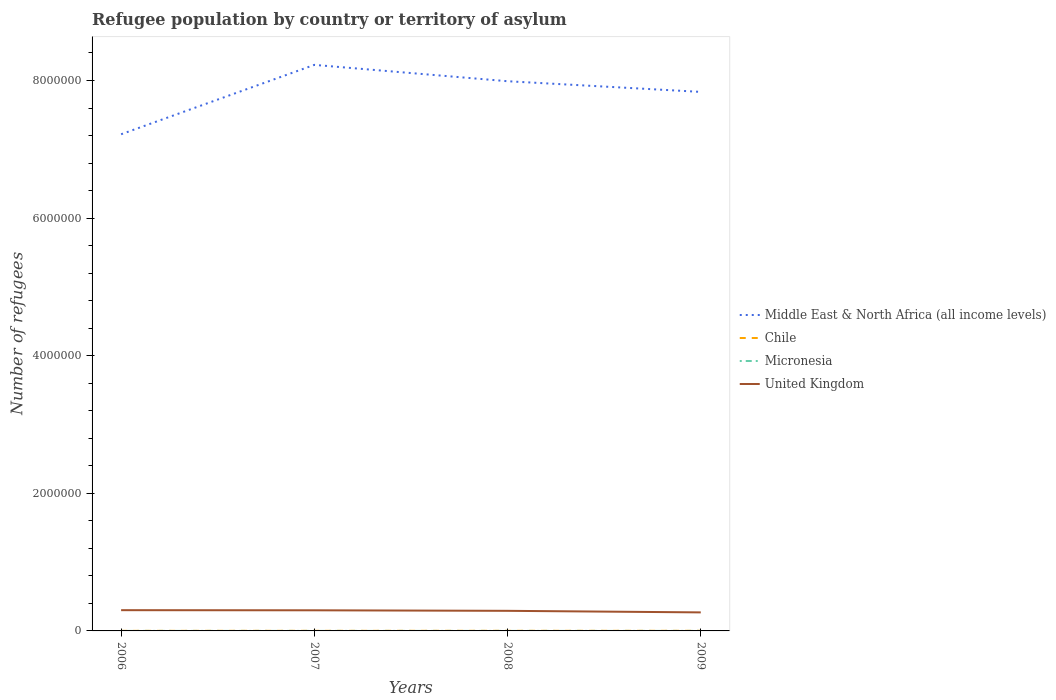Does the line corresponding to Micronesia intersect with the line corresponding to United Kingdom?
Make the answer very short. No. Across all years, what is the maximum number of refugees in Chile?
Provide a short and direct response. 1134. In which year was the number of refugees in Middle East & North Africa (all income levels) maximum?
Offer a terse response. 2006. What is the total number of refugees in Chile in the graph?
Offer a very short reply. -237. What is the difference between the highest and the second highest number of refugees in Middle East & North Africa (all income levels)?
Offer a very short reply. 1.01e+06. What is the difference between the highest and the lowest number of refugees in United Kingdom?
Provide a succinct answer. 3. Where does the legend appear in the graph?
Offer a very short reply. Center right. What is the title of the graph?
Offer a very short reply. Refugee population by country or territory of asylum. Does "Armenia" appear as one of the legend labels in the graph?
Keep it short and to the point. No. What is the label or title of the Y-axis?
Your response must be concise. Number of refugees. What is the Number of refugees of Middle East & North Africa (all income levels) in 2006?
Your answer should be compact. 7.22e+06. What is the Number of refugees in Chile in 2006?
Your response must be concise. 1134. What is the Number of refugees of United Kingdom in 2006?
Ensure brevity in your answer.  3.02e+05. What is the Number of refugees of Middle East & North Africa (all income levels) in 2007?
Your response must be concise. 8.23e+06. What is the Number of refugees in Chile in 2007?
Keep it short and to the point. 1376. What is the Number of refugees in United Kingdom in 2007?
Offer a terse response. 3.00e+05. What is the Number of refugees of Middle East & North Africa (all income levels) in 2008?
Offer a very short reply. 7.99e+06. What is the Number of refugees of Chile in 2008?
Ensure brevity in your answer.  1613. What is the Number of refugees in United Kingdom in 2008?
Your answer should be compact. 2.92e+05. What is the Number of refugees in Middle East & North Africa (all income levels) in 2009?
Your response must be concise. 7.83e+06. What is the Number of refugees in Chile in 2009?
Ensure brevity in your answer.  1539. What is the Number of refugees in Micronesia in 2009?
Provide a succinct answer. 1. What is the Number of refugees of United Kingdom in 2009?
Provide a succinct answer. 2.69e+05. Across all years, what is the maximum Number of refugees in Middle East & North Africa (all income levels)?
Give a very brief answer. 8.23e+06. Across all years, what is the maximum Number of refugees in Chile?
Offer a very short reply. 1613. Across all years, what is the maximum Number of refugees of United Kingdom?
Offer a terse response. 3.02e+05. Across all years, what is the minimum Number of refugees in Middle East & North Africa (all income levels)?
Provide a succinct answer. 7.22e+06. Across all years, what is the minimum Number of refugees in Chile?
Give a very brief answer. 1134. Across all years, what is the minimum Number of refugees in United Kingdom?
Provide a succinct answer. 2.69e+05. What is the total Number of refugees in Middle East & North Africa (all income levels) in the graph?
Offer a terse response. 3.13e+07. What is the total Number of refugees of Chile in the graph?
Provide a short and direct response. 5662. What is the total Number of refugees in Micronesia in the graph?
Keep it short and to the point. 6. What is the total Number of refugees of United Kingdom in the graph?
Give a very brief answer. 1.16e+06. What is the difference between the Number of refugees of Middle East & North Africa (all income levels) in 2006 and that in 2007?
Give a very brief answer. -1.01e+06. What is the difference between the Number of refugees of Chile in 2006 and that in 2007?
Your answer should be very brief. -242. What is the difference between the Number of refugees of United Kingdom in 2006 and that in 2007?
Your answer should be compact. 1838. What is the difference between the Number of refugees of Middle East & North Africa (all income levels) in 2006 and that in 2008?
Offer a very short reply. -7.71e+05. What is the difference between the Number of refugees in Chile in 2006 and that in 2008?
Offer a terse response. -479. What is the difference between the Number of refugees of United Kingdom in 2006 and that in 2008?
Give a very brief answer. 9459. What is the difference between the Number of refugees in Middle East & North Africa (all income levels) in 2006 and that in 2009?
Your answer should be compact. -6.16e+05. What is the difference between the Number of refugees of Chile in 2006 and that in 2009?
Offer a very short reply. -405. What is the difference between the Number of refugees in Micronesia in 2006 and that in 2009?
Make the answer very short. 1. What is the difference between the Number of refugees of United Kingdom in 2006 and that in 2009?
Offer a very short reply. 3.22e+04. What is the difference between the Number of refugees of Middle East & North Africa (all income levels) in 2007 and that in 2008?
Your answer should be compact. 2.38e+05. What is the difference between the Number of refugees in Chile in 2007 and that in 2008?
Provide a succinct answer. -237. What is the difference between the Number of refugees of United Kingdom in 2007 and that in 2008?
Make the answer very short. 7621. What is the difference between the Number of refugees in Middle East & North Africa (all income levels) in 2007 and that in 2009?
Offer a very short reply. 3.93e+05. What is the difference between the Number of refugees of Chile in 2007 and that in 2009?
Provide a succinct answer. -163. What is the difference between the Number of refugees of Micronesia in 2007 and that in 2009?
Provide a short and direct response. 1. What is the difference between the Number of refugees of United Kingdom in 2007 and that in 2009?
Provide a short and direct response. 3.04e+04. What is the difference between the Number of refugees in Middle East & North Africa (all income levels) in 2008 and that in 2009?
Give a very brief answer. 1.55e+05. What is the difference between the Number of refugees of Chile in 2008 and that in 2009?
Your answer should be very brief. 74. What is the difference between the Number of refugees in United Kingdom in 2008 and that in 2009?
Make the answer very short. 2.27e+04. What is the difference between the Number of refugees of Middle East & North Africa (all income levels) in 2006 and the Number of refugees of Chile in 2007?
Offer a terse response. 7.22e+06. What is the difference between the Number of refugees in Middle East & North Africa (all income levels) in 2006 and the Number of refugees in Micronesia in 2007?
Ensure brevity in your answer.  7.22e+06. What is the difference between the Number of refugees of Middle East & North Africa (all income levels) in 2006 and the Number of refugees of United Kingdom in 2007?
Your answer should be very brief. 6.92e+06. What is the difference between the Number of refugees of Chile in 2006 and the Number of refugees of Micronesia in 2007?
Give a very brief answer. 1132. What is the difference between the Number of refugees in Chile in 2006 and the Number of refugees in United Kingdom in 2007?
Provide a succinct answer. -2.99e+05. What is the difference between the Number of refugees in Micronesia in 2006 and the Number of refugees in United Kingdom in 2007?
Make the answer very short. -3.00e+05. What is the difference between the Number of refugees of Middle East & North Africa (all income levels) in 2006 and the Number of refugees of Chile in 2008?
Make the answer very short. 7.22e+06. What is the difference between the Number of refugees in Middle East & North Africa (all income levels) in 2006 and the Number of refugees in Micronesia in 2008?
Your answer should be very brief. 7.22e+06. What is the difference between the Number of refugees in Middle East & North Africa (all income levels) in 2006 and the Number of refugees in United Kingdom in 2008?
Ensure brevity in your answer.  6.93e+06. What is the difference between the Number of refugees of Chile in 2006 and the Number of refugees of Micronesia in 2008?
Keep it short and to the point. 1133. What is the difference between the Number of refugees of Chile in 2006 and the Number of refugees of United Kingdom in 2008?
Offer a very short reply. -2.91e+05. What is the difference between the Number of refugees of Micronesia in 2006 and the Number of refugees of United Kingdom in 2008?
Your answer should be compact. -2.92e+05. What is the difference between the Number of refugees of Middle East & North Africa (all income levels) in 2006 and the Number of refugees of Chile in 2009?
Provide a short and direct response. 7.22e+06. What is the difference between the Number of refugees of Middle East & North Africa (all income levels) in 2006 and the Number of refugees of Micronesia in 2009?
Offer a very short reply. 7.22e+06. What is the difference between the Number of refugees in Middle East & North Africa (all income levels) in 2006 and the Number of refugees in United Kingdom in 2009?
Give a very brief answer. 6.95e+06. What is the difference between the Number of refugees in Chile in 2006 and the Number of refugees in Micronesia in 2009?
Your response must be concise. 1133. What is the difference between the Number of refugees of Chile in 2006 and the Number of refugees of United Kingdom in 2009?
Keep it short and to the point. -2.68e+05. What is the difference between the Number of refugees in Micronesia in 2006 and the Number of refugees in United Kingdom in 2009?
Your answer should be compact. -2.69e+05. What is the difference between the Number of refugees in Middle East & North Africa (all income levels) in 2007 and the Number of refugees in Chile in 2008?
Your answer should be very brief. 8.23e+06. What is the difference between the Number of refugees in Middle East & North Africa (all income levels) in 2007 and the Number of refugees in Micronesia in 2008?
Ensure brevity in your answer.  8.23e+06. What is the difference between the Number of refugees in Middle East & North Africa (all income levels) in 2007 and the Number of refugees in United Kingdom in 2008?
Keep it short and to the point. 7.93e+06. What is the difference between the Number of refugees in Chile in 2007 and the Number of refugees in Micronesia in 2008?
Provide a short and direct response. 1375. What is the difference between the Number of refugees of Chile in 2007 and the Number of refugees of United Kingdom in 2008?
Make the answer very short. -2.91e+05. What is the difference between the Number of refugees in Micronesia in 2007 and the Number of refugees in United Kingdom in 2008?
Your response must be concise. -2.92e+05. What is the difference between the Number of refugees in Middle East & North Africa (all income levels) in 2007 and the Number of refugees in Chile in 2009?
Make the answer very short. 8.23e+06. What is the difference between the Number of refugees in Middle East & North Africa (all income levels) in 2007 and the Number of refugees in Micronesia in 2009?
Provide a short and direct response. 8.23e+06. What is the difference between the Number of refugees in Middle East & North Africa (all income levels) in 2007 and the Number of refugees in United Kingdom in 2009?
Keep it short and to the point. 7.96e+06. What is the difference between the Number of refugees of Chile in 2007 and the Number of refugees of Micronesia in 2009?
Ensure brevity in your answer.  1375. What is the difference between the Number of refugees in Chile in 2007 and the Number of refugees in United Kingdom in 2009?
Your response must be concise. -2.68e+05. What is the difference between the Number of refugees in Micronesia in 2007 and the Number of refugees in United Kingdom in 2009?
Make the answer very short. -2.69e+05. What is the difference between the Number of refugees in Middle East & North Africa (all income levels) in 2008 and the Number of refugees in Chile in 2009?
Your response must be concise. 7.99e+06. What is the difference between the Number of refugees in Middle East & North Africa (all income levels) in 2008 and the Number of refugees in Micronesia in 2009?
Offer a very short reply. 7.99e+06. What is the difference between the Number of refugees in Middle East & North Africa (all income levels) in 2008 and the Number of refugees in United Kingdom in 2009?
Provide a succinct answer. 7.72e+06. What is the difference between the Number of refugees in Chile in 2008 and the Number of refugees in Micronesia in 2009?
Offer a very short reply. 1612. What is the difference between the Number of refugees of Chile in 2008 and the Number of refugees of United Kingdom in 2009?
Provide a succinct answer. -2.68e+05. What is the difference between the Number of refugees in Micronesia in 2008 and the Number of refugees in United Kingdom in 2009?
Ensure brevity in your answer.  -2.69e+05. What is the average Number of refugees in Middle East & North Africa (all income levels) per year?
Ensure brevity in your answer.  7.82e+06. What is the average Number of refugees in Chile per year?
Provide a short and direct response. 1415.5. What is the average Number of refugees of Micronesia per year?
Offer a terse response. 1.5. What is the average Number of refugees in United Kingdom per year?
Offer a terse response. 2.91e+05. In the year 2006, what is the difference between the Number of refugees in Middle East & North Africa (all income levels) and Number of refugees in Chile?
Keep it short and to the point. 7.22e+06. In the year 2006, what is the difference between the Number of refugees of Middle East & North Africa (all income levels) and Number of refugees of Micronesia?
Your answer should be very brief. 7.22e+06. In the year 2006, what is the difference between the Number of refugees in Middle East & North Africa (all income levels) and Number of refugees in United Kingdom?
Offer a very short reply. 6.92e+06. In the year 2006, what is the difference between the Number of refugees of Chile and Number of refugees of Micronesia?
Keep it short and to the point. 1132. In the year 2006, what is the difference between the Number of refugees of Chile and Number of refugees of United Kingdom?
Ensure brevity in your answer.  -3.00e+05. In the year 2006, what is the difference between the Number of refugees of Micronesia and Number of refugees of United Kingdom?
Keep it short and to the point. -3.02e+05. In the year 2007, what is the difference between the Number of refugees of Middle East & North Africa (all income levels) and Number of refugees of Chile?
Your response must be concise. 8.23e+06. In the year 2007, what is the difference between the Number of refugees in Middle East & North Africa (all income levels) and Number of refugees in Micronesia?
Your answer should be compact. 8.23e+06. In the year 2007, what is the difference between the Number of refugees in Middle East & North Africa (all income levels) and Number of refugees in United Kingdom?
Your answer should be very brief. 7.93e+06. In the year 2007, what is the difference between the Number of refugees of Chile and Number of refugees of Micronesia?
Make the answer very short. 1374. In the year 2007, what is the difference between the Number of refugees of Chile and Number of refugees of United Kingdom?
Your response must be concise. -2.98e+05. In the year 2007, what is the difference between the Number of refugees of Micronesia and Number of refugees of United Kingdom?
Offer a very short reply. -3.00e+05. In the year 2008, what is the difference between the Number of refugees of Middle East & North Africa (all income levels) and Number of refugees of Chile?
Ensure brevity in your answer.  7.99e+06. In the year 2008, what is the difference between the Number of refugees in Middle East & North Africa (all income levels) and Number of refugees in Micronesia?
Provide a succinct answer. 7.99e+06. In the year 2008, what is the difference between the Number of refugees of Middle East & North Africa (all income levels) and Number of refugees of United Kingdom?
Your answer should be compact. 7.70e+06. In the year 2008, what is the difference between the Number of refugees in Chile and Number of refugees in Micronesia?
Make the answer very short. 1612. In the year 2008, what is the difference between the Number of refugees of Chile and Number of refugees of United Kingdom?
Make the answer very short. -2.90e+05. In the year 2008, what is the difference between the Number of refugees of Micronesia and Number of refugees of United Kingdom?
Offer a very short reply. -2.92e+05. In the year 2009, what is the difference between the Number of refugees in Middle East & North Africa (all income levels) and Number of refugees in Chile?
Give a very brief answer. 7.83e+06. In the year 2009, what is the difference between the Number of refugees of Middle East & North Africa (all income levels) and Number of refugees of Micronesia?
Provide a short and direct response. 7.83e+06. In the year 2009, what is the difference between the Number of refugees of Middle East & North Africa (all income levels) and Number of refugees of United Kingdom?
Your answer should be compact. 7.56e+06. In the year 2009, what is the difference between the Number of refugees of Chile and Number of refugees of Micronesia?
Offer a very short reply. 1538. In the year 2009, what is the difference between the Number of refugees in Chile and Number of refugees in United Kingdom?
Your answer should be compact. -2.68e+05. In the year 2009, what is the difference between the Number of refugees of Micronesia and Number of refugees of United Kingdom?
Offer a very short reply. -2.69e+05. What is the ratio of the Number of refugees in Middle East & North Africa (all income levels) in 2006 to that in 2007?
Offer a very short reply. 0.88. What is the ratio of the Number of refugees in Chile in 2006 to that in 2007?
Keep it short and to the point. 0.82. What is the ratio of the Number of refugees of Middle East & North Africa (all income levels) in 2006 to that in 2008?
Your response must be concise. 0.9. What is the ratio of the Number of refugees in Chile in 2006 to that in 2008?
Provide a succinct answer. 0.7. What is the ratio of the Number of refugees of Micronesia in 2006 to that in 2008?
Your answer should be compact. 2. What is the ratio of the Number of refugees of United Kingdom in 2006 to that in 2008?
Keep it short and to the point. 1.03. What is the ratio of the Number of refugees in Middle East & North Africa (all income levels) in 2006 to that in 2009?
Provide a succinct answer. 0.92. What is the ratio of the Number of refugees of Chile in 2006 to that in 2009?
Ensure brevity in your answer.  0.74. What is the ratio of the Number of refugees in Micronesia in 2006 to that in 2009?
Offer a very short reply. 2. What is the ratio of the Number of refugees of United Kingdom in 2006 to that in 2009?
Your answer should be very brief. 1.12. What is the ratio of the Number of refugees of Middle East & North Africa (all income levels) in 2007 to that in 2008?
Offer a terse response. 1.03. What is the ratio of the Number of refugees of Chile in 2007 to that in 2008?
Give a very brief answer. 0.85. What is the ratio of the Number of refugees of Micronesia in 2007 to that in 2008?
Provide a succinct answer. 2. What is the ratio of the Number of refugees of United Kingdom in 2007 to that in 2008?
Keep it short and to the point. 1.03. What is the ratio of the Number of refugees of Middle East & North Africa (all income levels) in 2007 to that in 2009?
Offer a very short reply. 1.05. What is the ratio of the Number of refugees of Chile in 2007 to that in 2009?
Make the answer very short. 0.89. What is the ratio of the Number of refugees in United Kingdom in 2007 to that in 2009?
Make the answer very short. 1.11. What is the ratio of the Number of refugees in Middle East & North Africa (all income levels) in 2008 to that in 2009?
Make the answer very short. 1.02. What is the ratio of the Number of refugees in Chile in 2008 to that in 2009?
Provide a succinct answer. 1.05. What is the ratio of the Number of refugees of United Kingdom in 2008 to that in 2009?
Keep it short and to the point. 1.08. What is the difference between the highest and the second highest Number of refugees in Middle East & North Africa (all income levels)?
Keep it short and to the point. 2.38e+05. What is the difference between the highest and the second highest Number of refugees of United Kingdom?
Provide a succinct answer. 1838. What is the difference between the highest and the lowest Number of refugees in Middle East & North Africa (all income levels)?
Your answer should be compact. 1.01e+06. What is the difference between the highest and the lowest Number of refugees of Chile?
Your answer should be very brief. 479. What is the difference between the highest and the lowest Number of refugees of Micronesia?
Your response must be concise. 1. What is the difference between the highest and the lowest Number of refugees in United Kingdom?
Ensure brevity in your answer.  3.22e+04. 